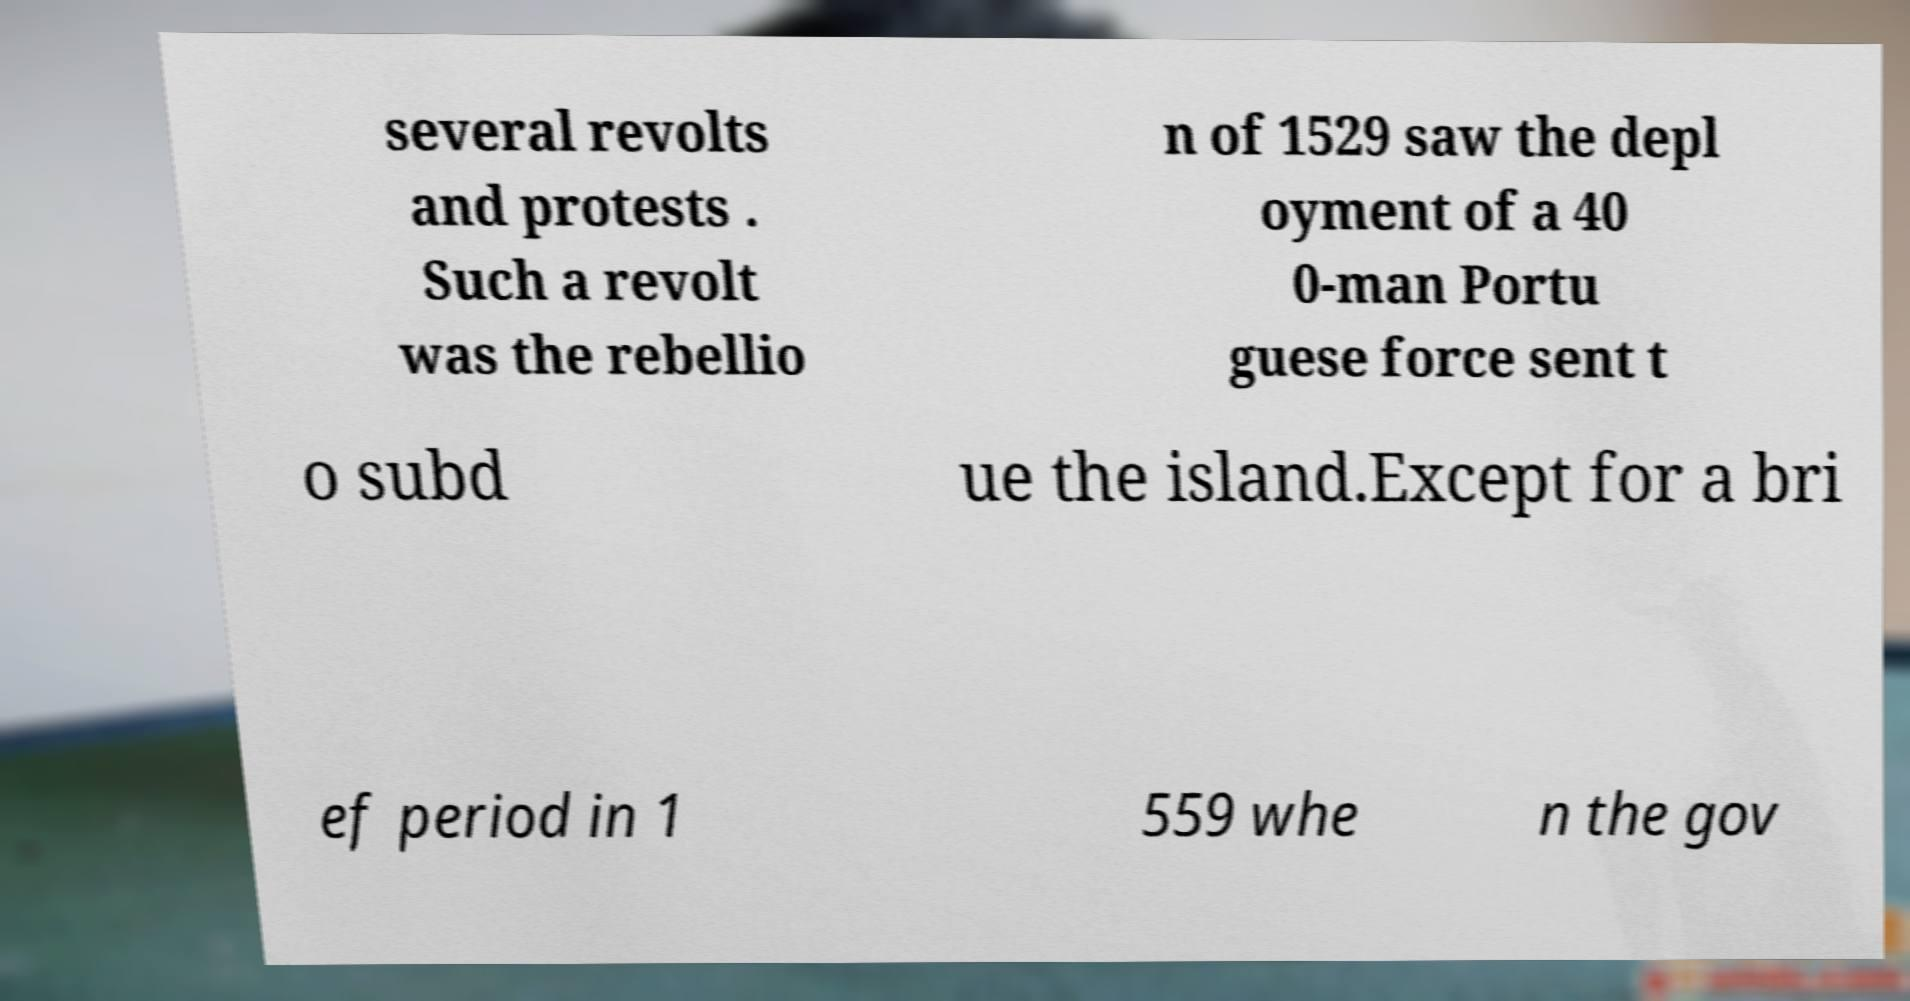There's text embedded in this image that I need extracted. Can you transcribe it verbatim? several revolts and protests . Such a revolt was the rebellio n of 1529 saw the depl oyment of a 40 0-man Portu guese force sent t o subd ue the island.Except for a bri ef period in 1 559 whe n the gov 